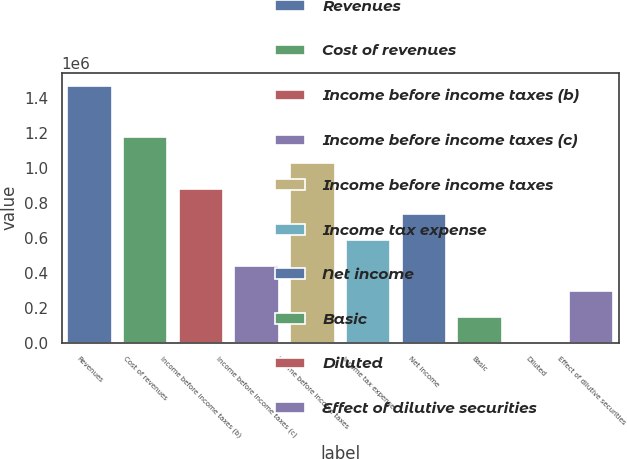<chart> <loc_0><loc_0><loc_500><loc_500><bar_chart><fcel>Revenues<fcel>Cost of revenues<fcel>Income before income taxes (b)<fcel>Income before income taxes (c)<fcel>Income before income taxes<fcel>Income tax expense<fcel>Net income<fcel>Basic<fcel>Diluted<fcel>Effect of dilutive securities<nl><fcel>1.46778e+06<fcel>1.17422e+06<fcel>880668<fcel>440334<fcel>1.02745e+06<fcel>587112<fcel>733890<fcel>146778<fcel>0.3<fcel>293556<nl></chart> 